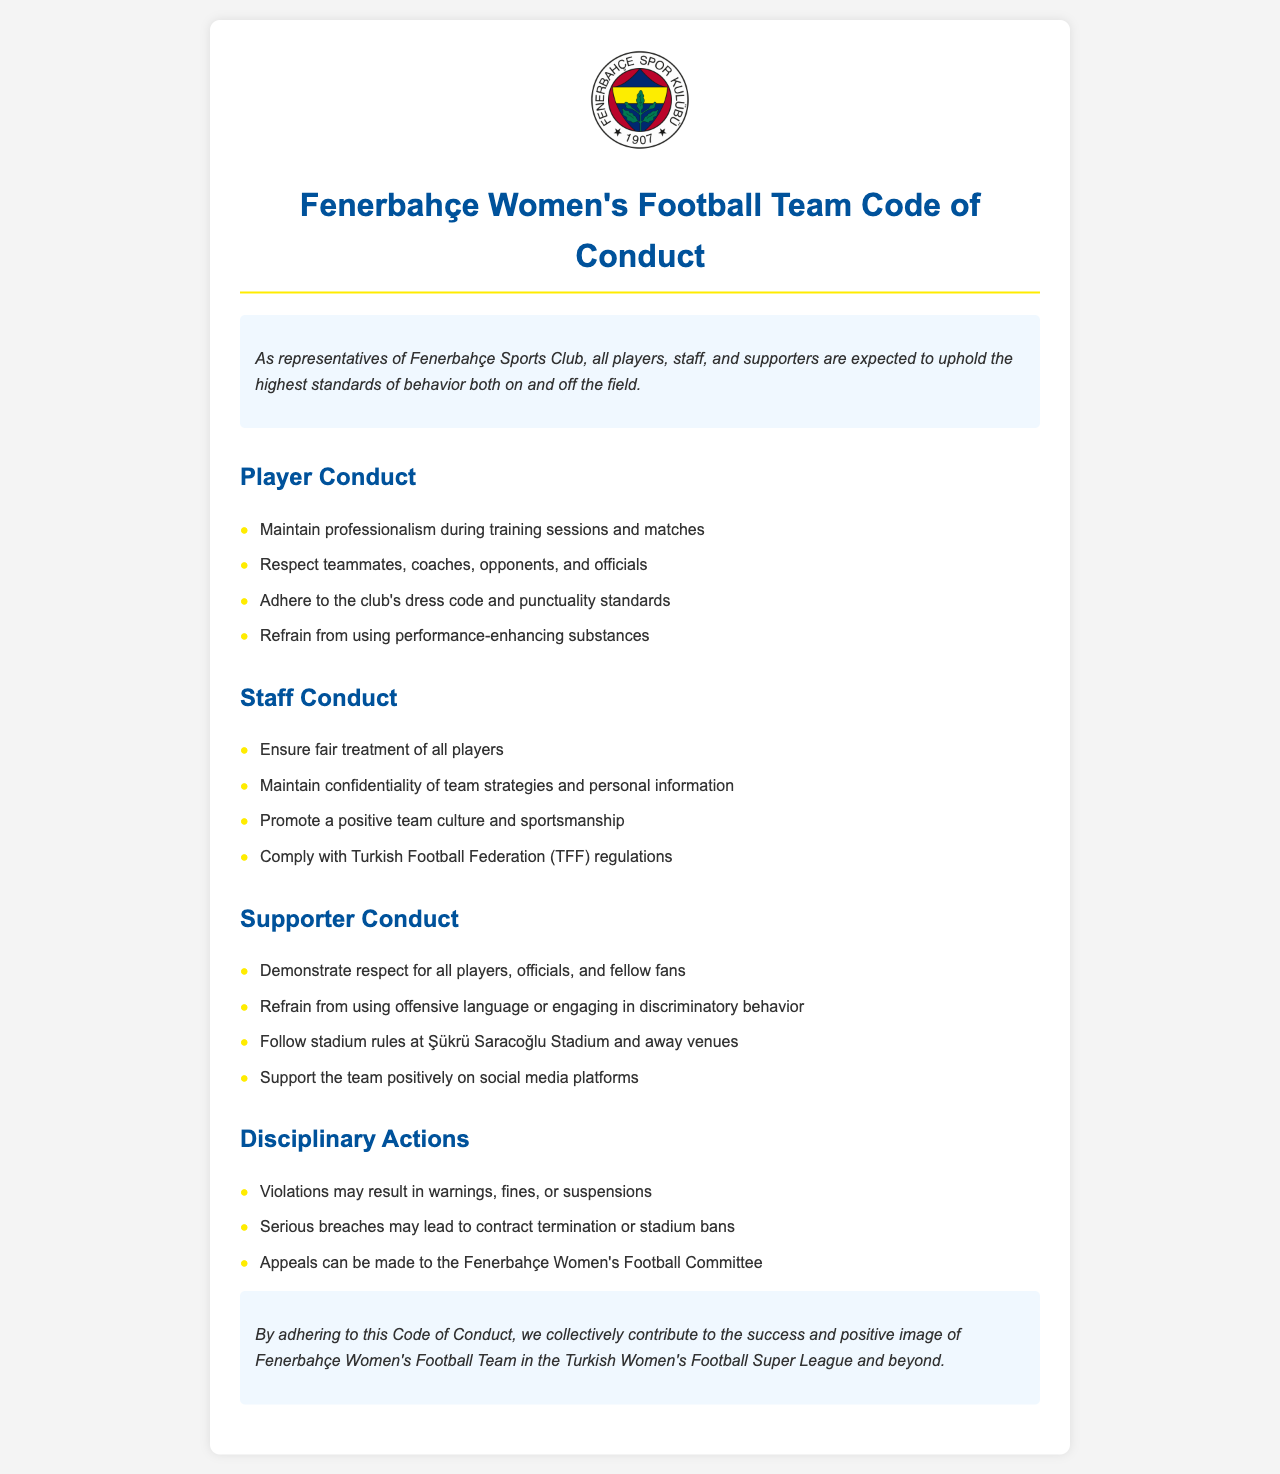what is the title of the document? The title is clearly stated at the top of the document as "Fenerbahçe Women's Football Team Code of Conduct".
Answer: Fenerbahçe Women's Football Team Code of Conduct who must maintain professionalism during training sessions? The document specifies that "players" must maintain professionalism, indicating their role in the club's conduct.
Answer: Players what should supporters refrain from using according to the guidelines? The guidelines instruct supporters to refrain from "using offensive language" which is a specific point outlined for supporter conduct.
Answer: Offensive language what are potential disciplinary actions for violations? The document lists multiple disciplinary actions, one being "warnings, fines, or suspensions" which are measures for violations of the Code of Conduct.
Answer: Warnings, fines, or suspensions which organization's regulations must staff comply with? The guidelines for staff conduct specifically mention compliance with the "Turkish Football Federation (TFF)" regulations.
Answer: Turkish Football Federation (TFF) what is emphasized as vital for all representatives of the club? The introduction highlights the importance of "upholding the highest standards of behavior" for all players, staff, and supporters in the club.
Answer: Highest standards of behavior what consequence could serious breaches lead to? The document states that serious breaches may lead to "contract termination or stadium bans" as a significant consequence.
Answer: Contract termination or stadium bans what does the conclusion emphasize regarding the Code of Conduct? The conclusion stresses that adhering to the Code of Conduct contributes to "the success and positive image" of the Fenerbahçe Women's Football Team.
Answer: Success and positive image 